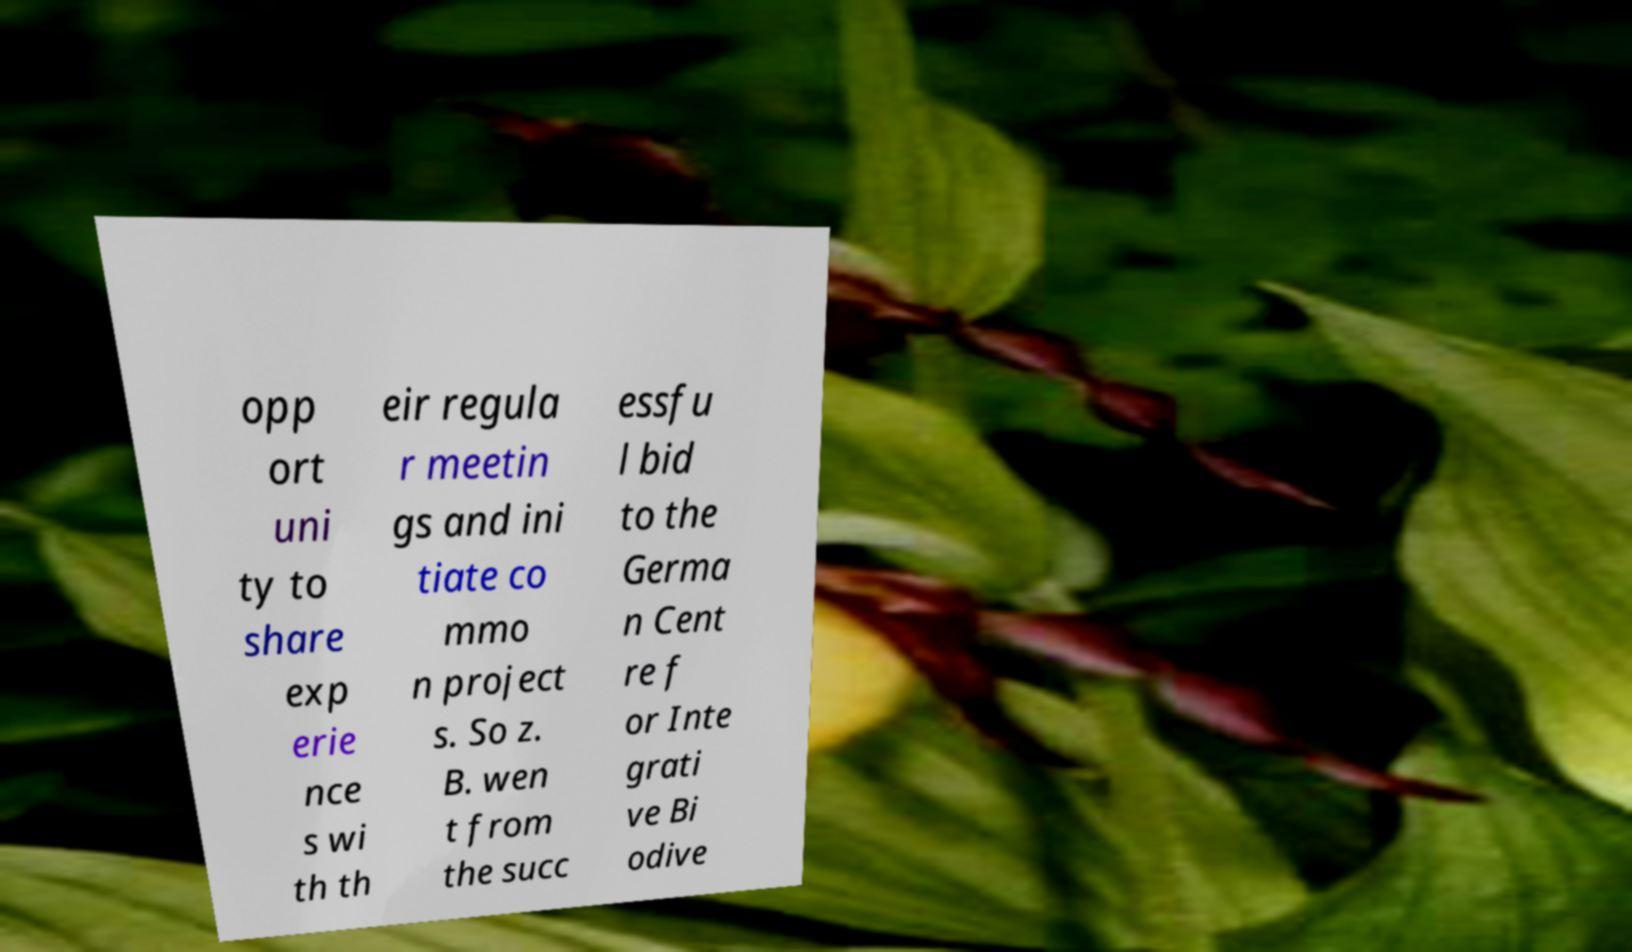Please read and relay the text visible in this image. What does it say? opp ort uni ty to share exp erie nce s wi th th eir regula r meetin gs and ini tiate co mmo n project s. So z. B. wen t from the succ essfu l bid to the Germa n Cent re f or Inte grati ve Bi odive 